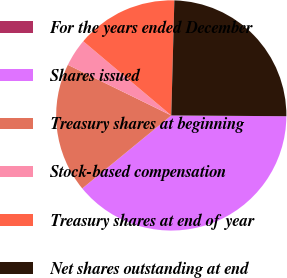Convert chart to OTSL. <chart><loc_0><loc_0><loc_500><loc_500><pie_chart><fcel>For the years ended December<fcel>Shares issued<fcel>Treasury shares at beginning<fcel>Stock-based compensation<fcel>Treasury shares at end of year<fcel>Net shares outstanding at end<nl><fcel>0.0%<fcel>38.96%<fcel>18.18%<fcel>3.9%<fcel>14.28%<fcel>24.68%<nl></chart> 